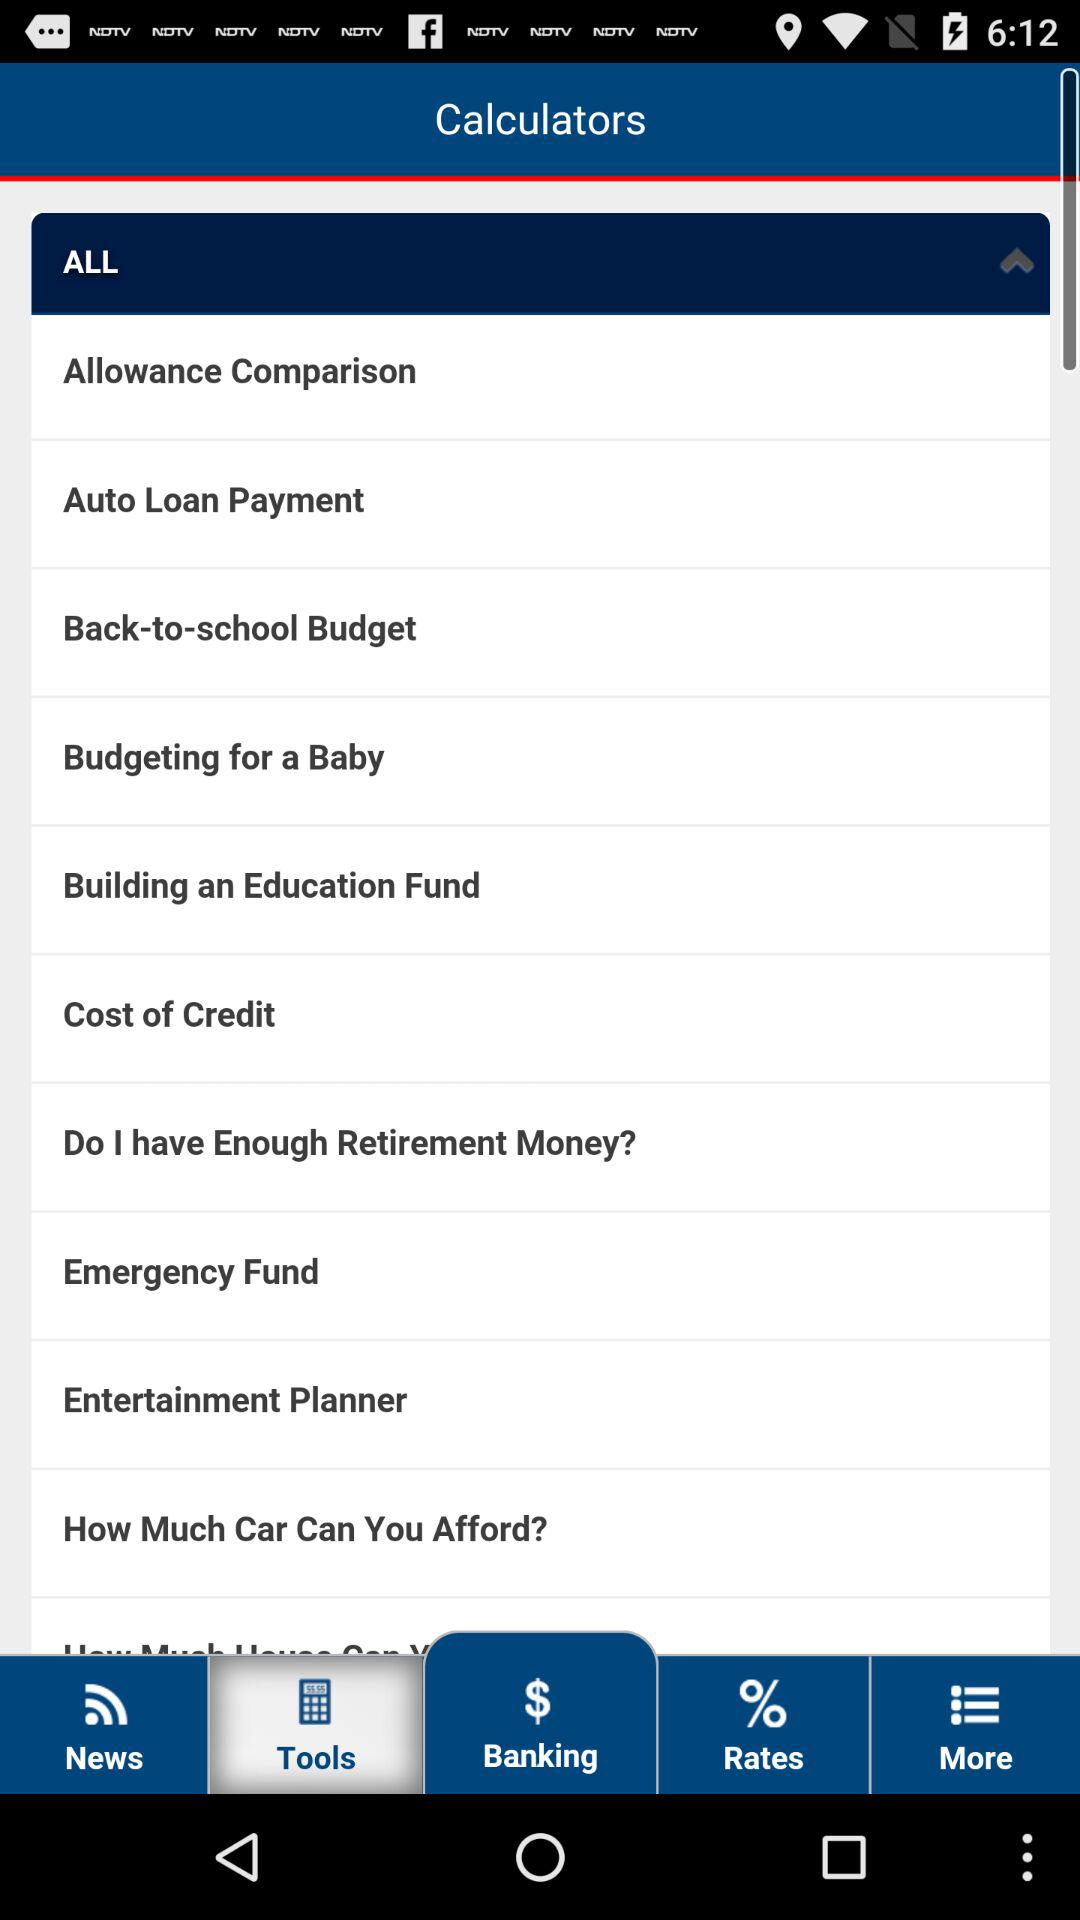How many notifications are there in "Rates"?
When the provided information is insufficient, respond with <no answer>. <no answer> 